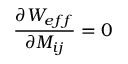<formula> <loc_0><loc_0><loc_500><loc_500>\frac { \partial W _ { e f f } } { \partial M _ { i j } } = 0</formula> 